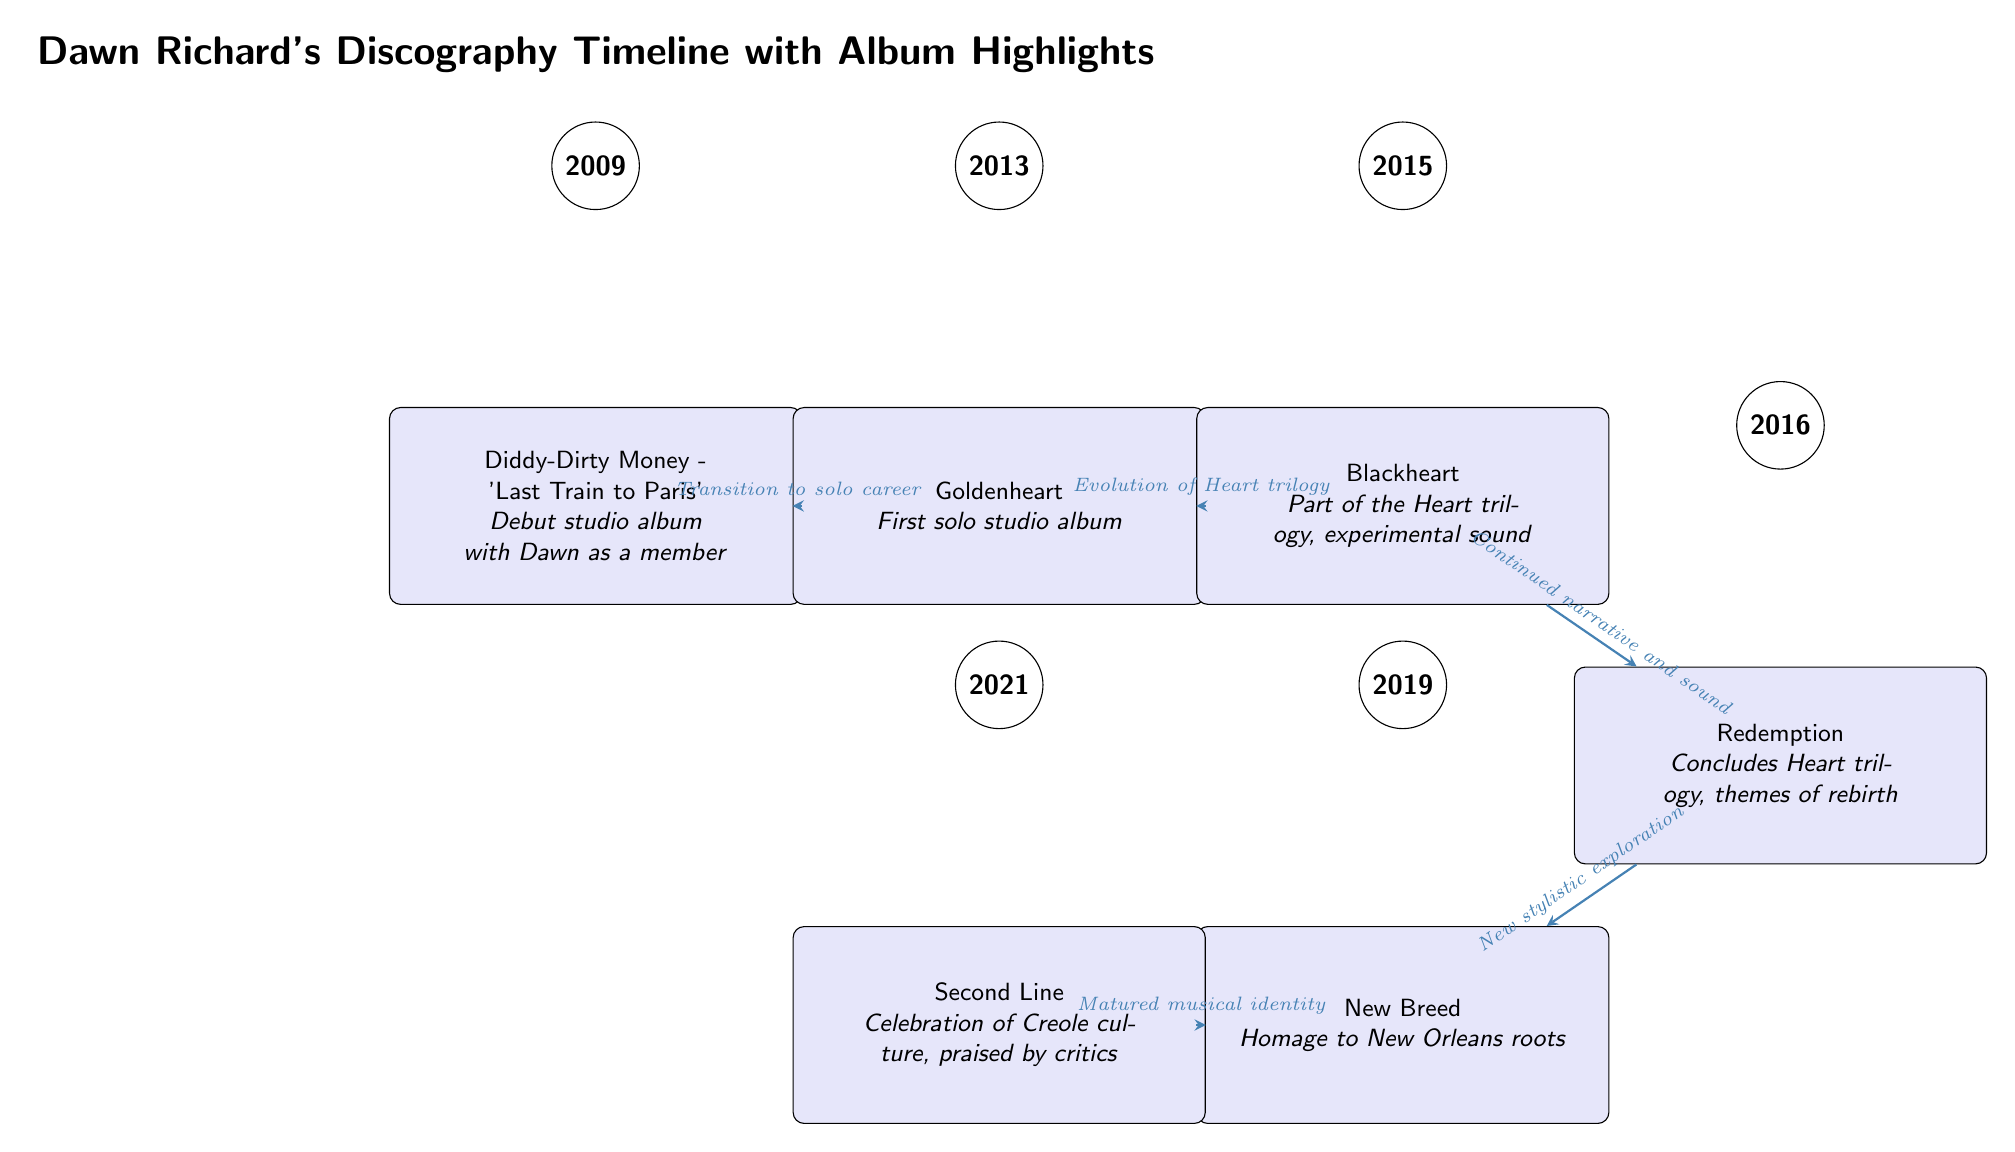What year was Dawn Richard's debut studio album released? The diagram specifies that Dawn Richard's debut studio album, 'Last Train to Paris' with Diddy-Dirty Money was released in 2009.
Answer: 2009 How many albums are shown in the diagram? By counting the album nodes in the diagram, we find a total of six albums listed, which includes both group and solo projects by Dawn Richard.
Answer: 6 What is the title of Dawn Richard's first solo studio album? The diagram indicates that the first solo studio album by Dawn Richard is titled 'Goldenheart,' which is positioned directly below the year 2013.
Answer: Goldenheart What theme is associated with the 'Redemption' album? The diagram notes that 'Redemption' concludes the Heart trilogy and is characterized by themes of rebirth, indicating a significant thematic focus.
Answer: Themes of rebirth What album follows 'Blackheart' in the timeline? The timeline shows that 'Redemption' is directly positioned below 'Blackheart,' making it the album that follows in the sequence of releases.
Answer: Redemption What significant transition does 'Goldenheart' mark for Dawn Richard? The diagram describes the transition to a solo career as a significant turning point associated with 'Goldenheart,' highlighting the shift away from collaboration in Diddy-Dirty Money.
Answer: Transition to solo career Which album is described as a homage to New Orleans roots? According to the diagram, 'New Breed' is specifically identified as an homage to New Orleans roots, marking its cultural significance in the timeline.
Answer: New Breed What type of sound does 'Blackheart' represent in Dawn's discography? The diagram explicitly labels 'Blackheart' as part of the Heart trilogy and describes it as having an experimental sound, illustrating its unique stylistic approach within her work.
Answer: Experimental sound 